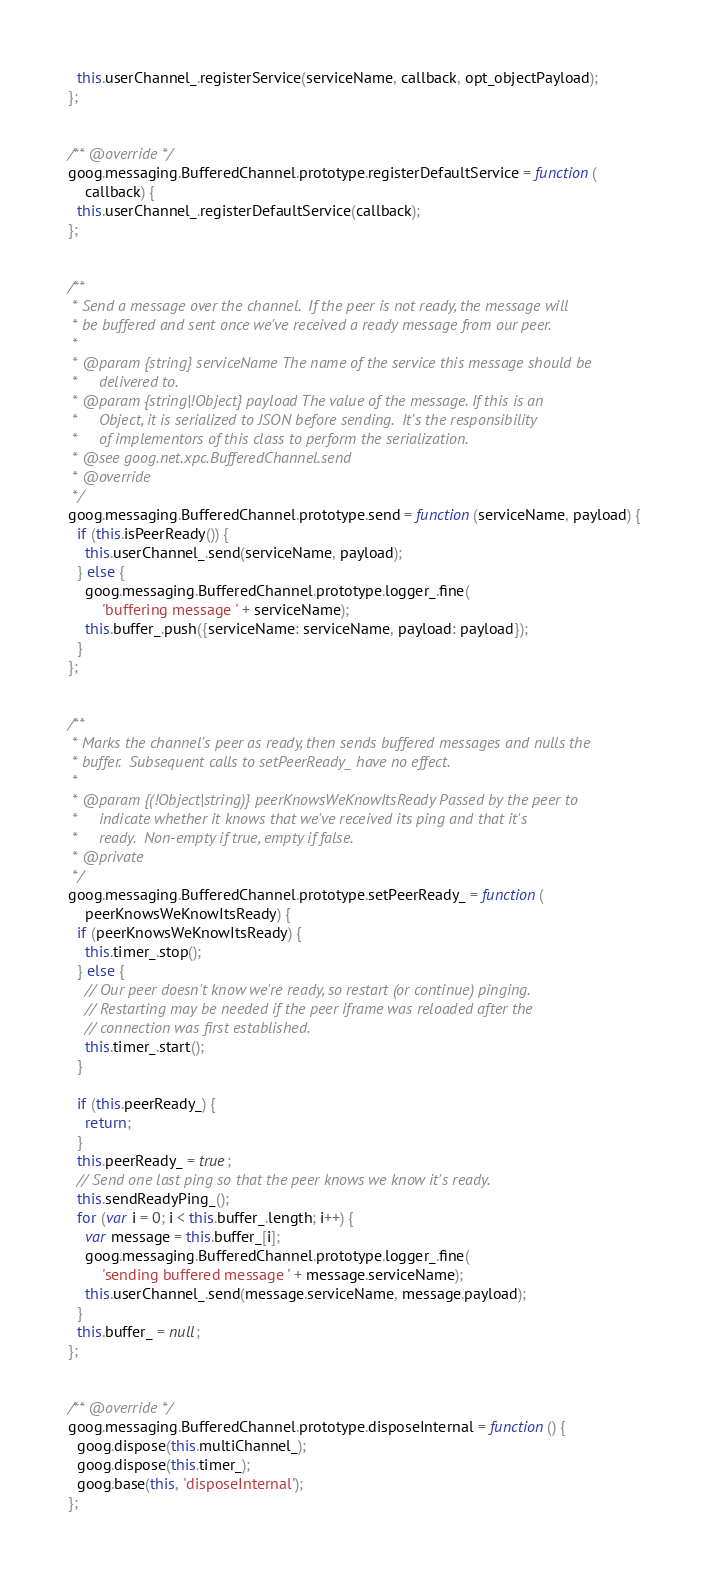Convert code to text. <code><loc_0><loc_0><loc_500><loc_500><_JavaScript_>  this.userChannel_.registerService(serviceName, callback, opt_objectPayload);
};


/** @override */
goog.messaging.BufferedChannel.prototype.registerDefaultService = function(
    callback) {
  this.userChannel_.registerDefaultService(callback);
};


/**
 * Send a message over the channel.  If the peer is not ready, the message will
 * be buffered and sent once we've received a ready message from our peer.
 *
 * @param {string} serviceName The name of the service this message should be
 *     delivered to.
 * @param {string|!Object} payload The value of the message. If this is an
 *     Object, it is serialized to JSON before sending.  It's the responsibility
 *     of implementors of this class to perform the serialization.
 * @see goog.net.xpc.BufferedChannel.send
 * @override
 */
goog.messaging.BufferedChannel.prototype.send = function(serviceName, payload) {
  if (this.isPeerReady()) {
    this.userChannel_.send(serviceName, payload);
  } else {
    goog.messaging.BufferedChannel.prototype.logger_.fine(
        'buffering message ' + serviceName);
    this.buffer_.push({serviceName: serviceName, payload: payload});
  }
};


/**
 * Marks the channel's peer as ready, then sends buffered messages and nulls the
 * buffer.  Subsequent calls to setPeerReady_ have no effect.
 *
 * @param {(!Object|string)} peerKnowsWeKnowItsReady Passed by the peer to
 *     indicate whether it knows that we've received its ping and that it's
 *     ready.  Non-empty if true, empty if false.
 * @private
 */
goog.messaging.BufferedChannel.prototype.setPeerReady_ = function(
    peerKnowsWeKnowItsReady) {
  if (peerKnowsWeKnowItsReady) {
    this.timer_.stop();
  } else {
    // Our peer doesn't know we're ready, so restart (or continue) pinging.
    // Restarting may be needed if the peer iframe was reloaded after the
    // connection was first established.
    this.timer_.start();
  }

  if (this.peerReady_) {
    return;
  }
  this.peerReady_ = true;
  // Send one last ping so that the peer knows we know it's ready.
  this.sendReadyPing_();
  for (var i = 0; i < this.buffer_.length; i++) {
    var message = this.buffer_[i];
    goog.messaging.BufferedChannel.prototype.logger_.fine(
        'sending buffered message ' + message.serviceName);
    this.userChannel_.send(message.serviceName, message.payload);
  }
  this.buffer_ = null;
};


/** @override */
goog.messaging.BufferedChannel.prototype.disposeInternal = function() {
  goog.dispose(this.multiChannel_);
  goog.dispose(this.timer_);
  goog.base(this, 'disposeInternal');
};
</code> 